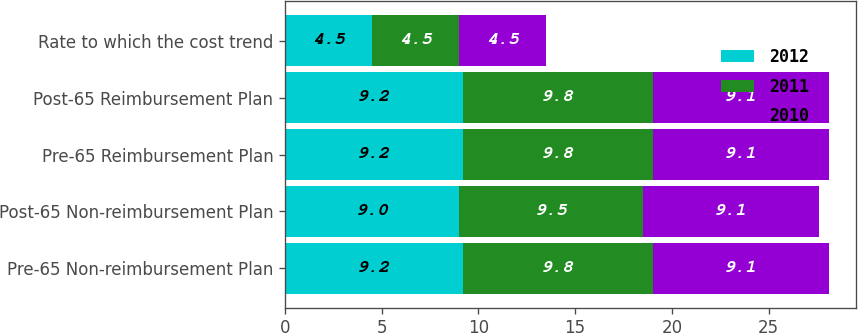Convert chart to OTSL. <chart><loc_0><loc_0><loc_500><loc_500><stacked_bar_chart><ecel><fcel>Pre-65 Non-reimbursement Plan<fcel>Post-65 Non-reimbursement Plan<fcel>Pre-65 Reimbursement Plan<fcel>Post-65 Reimbursement Plan<fcel>Rate to which the cost trend<nl><fcel>2012<fcel>9.2<fcel>9<fcel>9.2<fcel>9.2<fcel>4.5<nl><fcel>2011<fcel>9.8<fcel>9.5<fcel>9.8<fcel>9.8<fcel>4.5<nl><fcel>2010<fcel>9.1<fcel>9.1<fcel>9.1<fcel>9.1<fcel>4.5<nl></chart> 